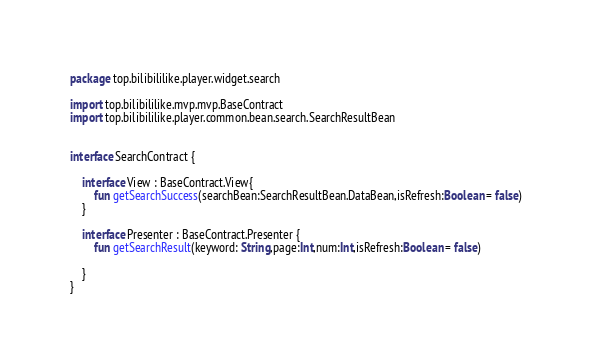<code> <loc_0><loc_0><loc_500><loc_500><_Kotlin_>package top.bilibililike.player.widget.search

import top.bilibililike.mvp.mvp.BaseContract
import top.bilibililike.player.common.bean.search.SearchResultBean


interface SearchContract {

    interface View : BaseContract.View{
        fun getSearchSuccess(searchBean:SearchResultBean.DataBean,isRefresh:Boolean = false)
    }

    interface Presenter : BaseContract.Presenter {
        fun getSearchResult(keyword: String,page:Int,num:Int,isRefresh:Boolean = false)

    }
}
</code> 